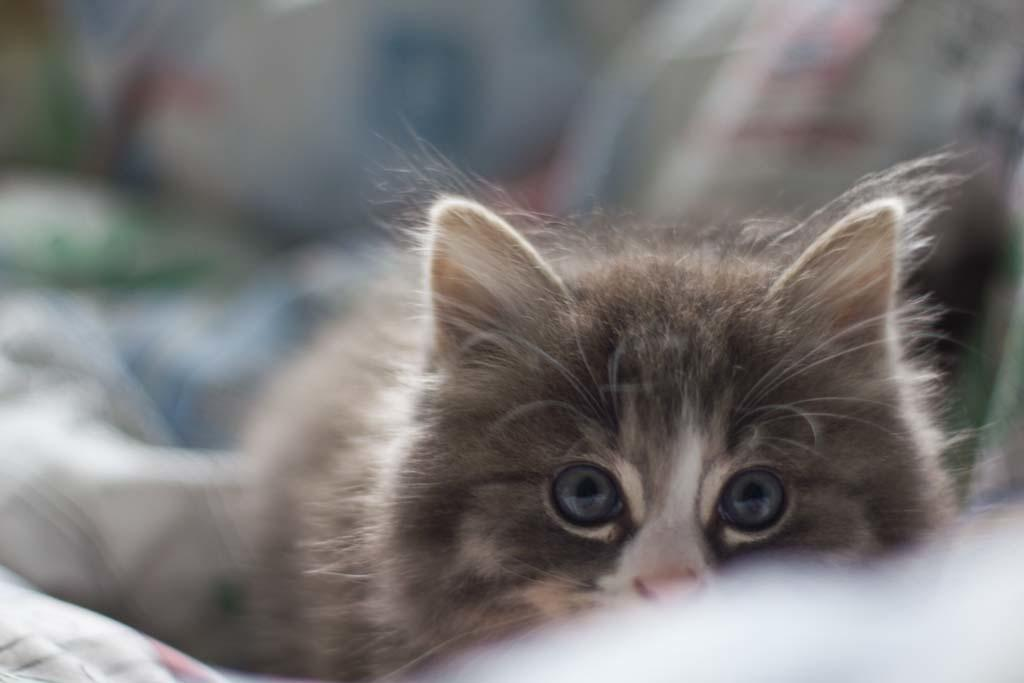What animal is present in the image? There is a cat in the image. What is the cat looking at? The cat is looking at a picture. What else can be seen near the cat? There are clothes near the cat. Can you describe the background of the image? The background of the image is blurred. How many dolls are balancing on the vase in the image? There are no dolls or vases present in the image. 